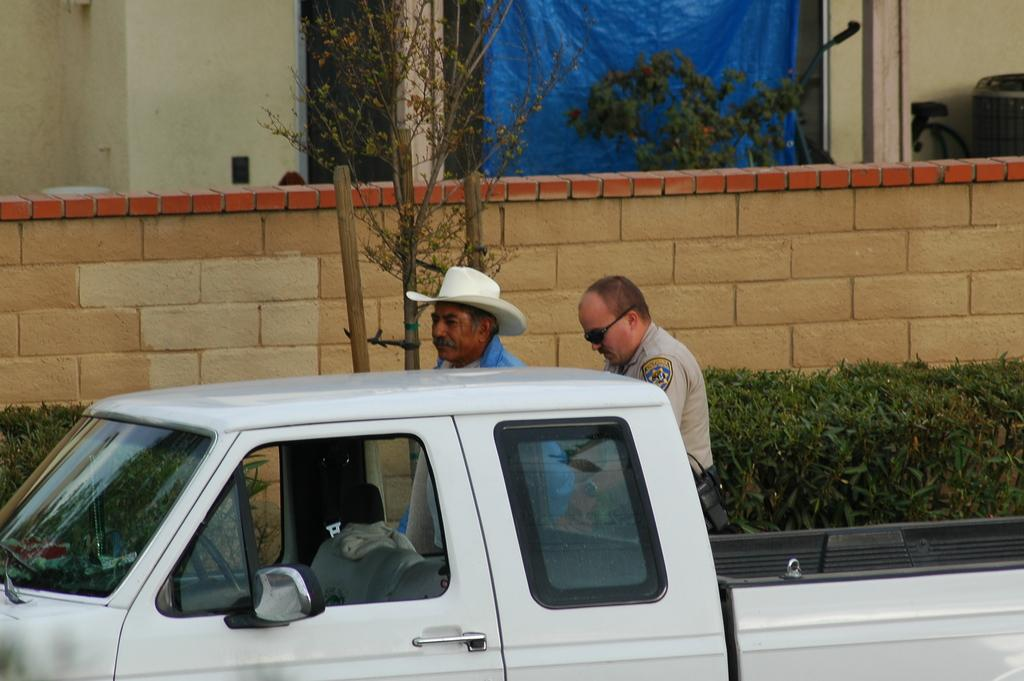What type of vehicle is in the image? There is a white truck in the image. Can you describe the people behind the truck? There are two people behind the truck. What can be seen in the image besides the truck and people? Plants, a wall, trees, a cover, a pole, and some objects are present in the image. Where is the cobweb located in the image? There is no cobweb present in the image. What type of carriage can be seen in the image? There is no carriage present in the image. 